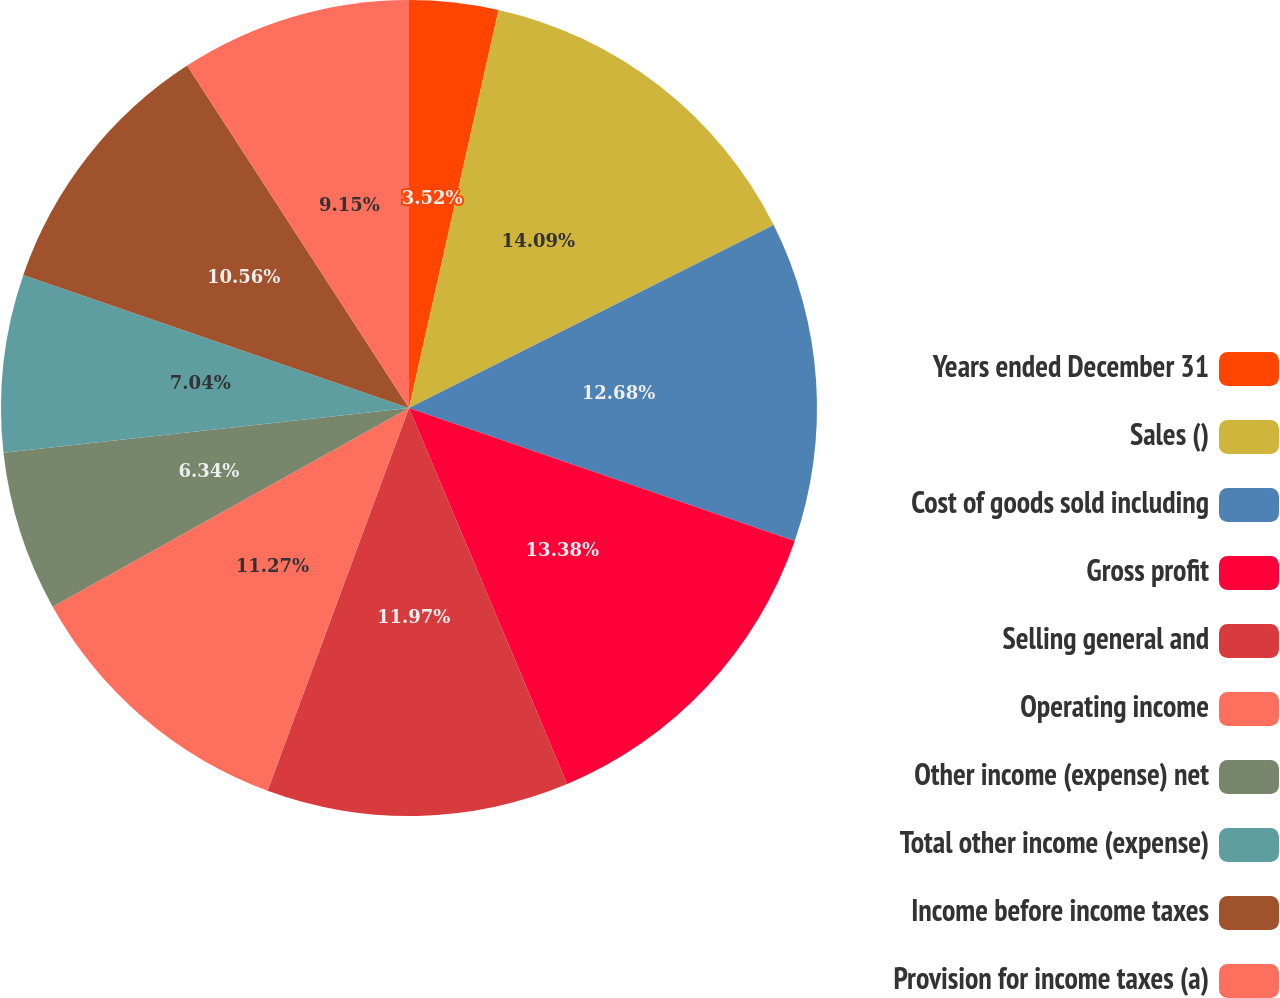Convert chart to OTSL. <chart><loc_0><loc_0><loc_500><loc_500><pie_chart><fcel>Years ended December 31<fcel>Sales ()<fcel>Cost of goods sold including<fcel>Gross profit<fcel>Selling general and<fcel>Operating income<fcel>Other income (expense) net<fcel>Total other income (expense)<fcel>Income before income taxes<fcel>Provision for income taxes (a)<nl><fcel>3.52%<fcel>14.08%<fcel>12.68%<fcel>13.38%<fcel>11.97%<fcel>11.27%<fcel>6.34%<fcel>7.04%<fcel>10.56%<fcel>9.15%<nl></chart> 